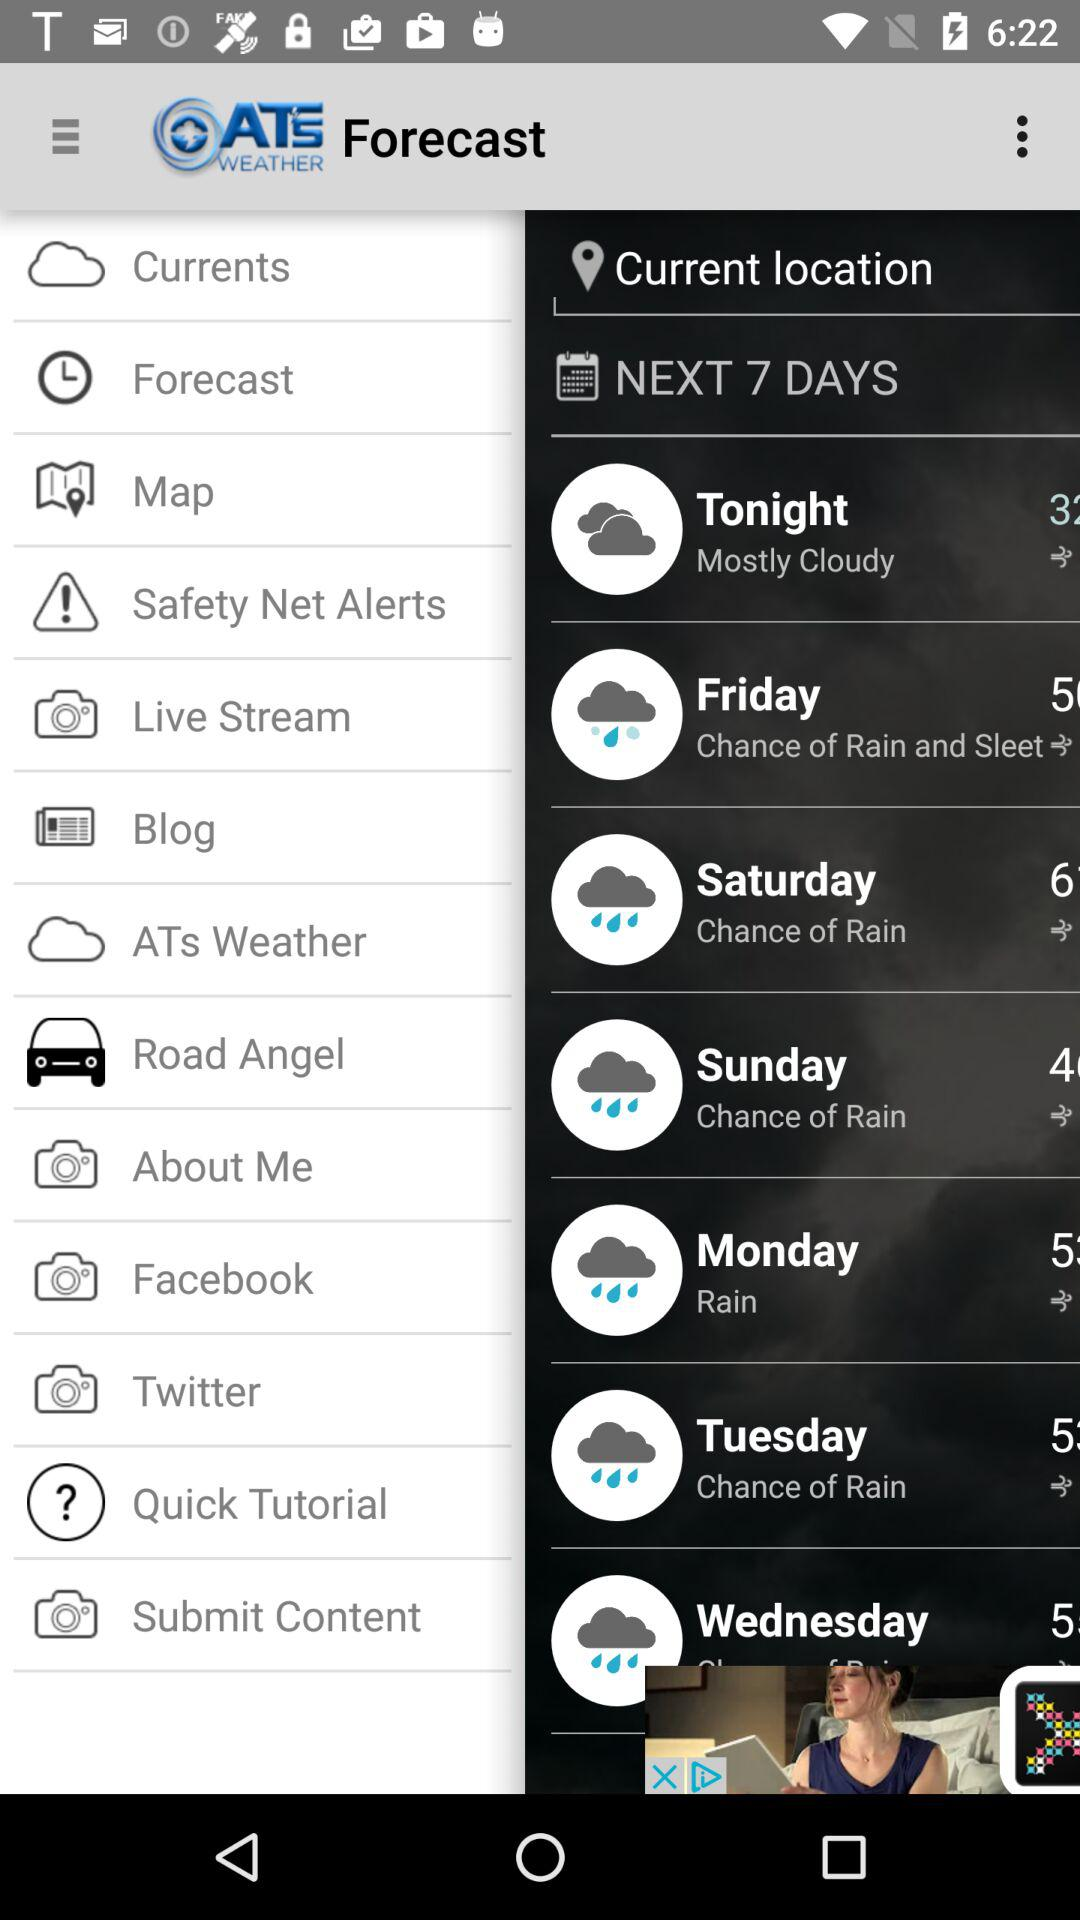What is temperature at friday?
When the provided information is insufficient, respond with <no answer>. <no answer> 